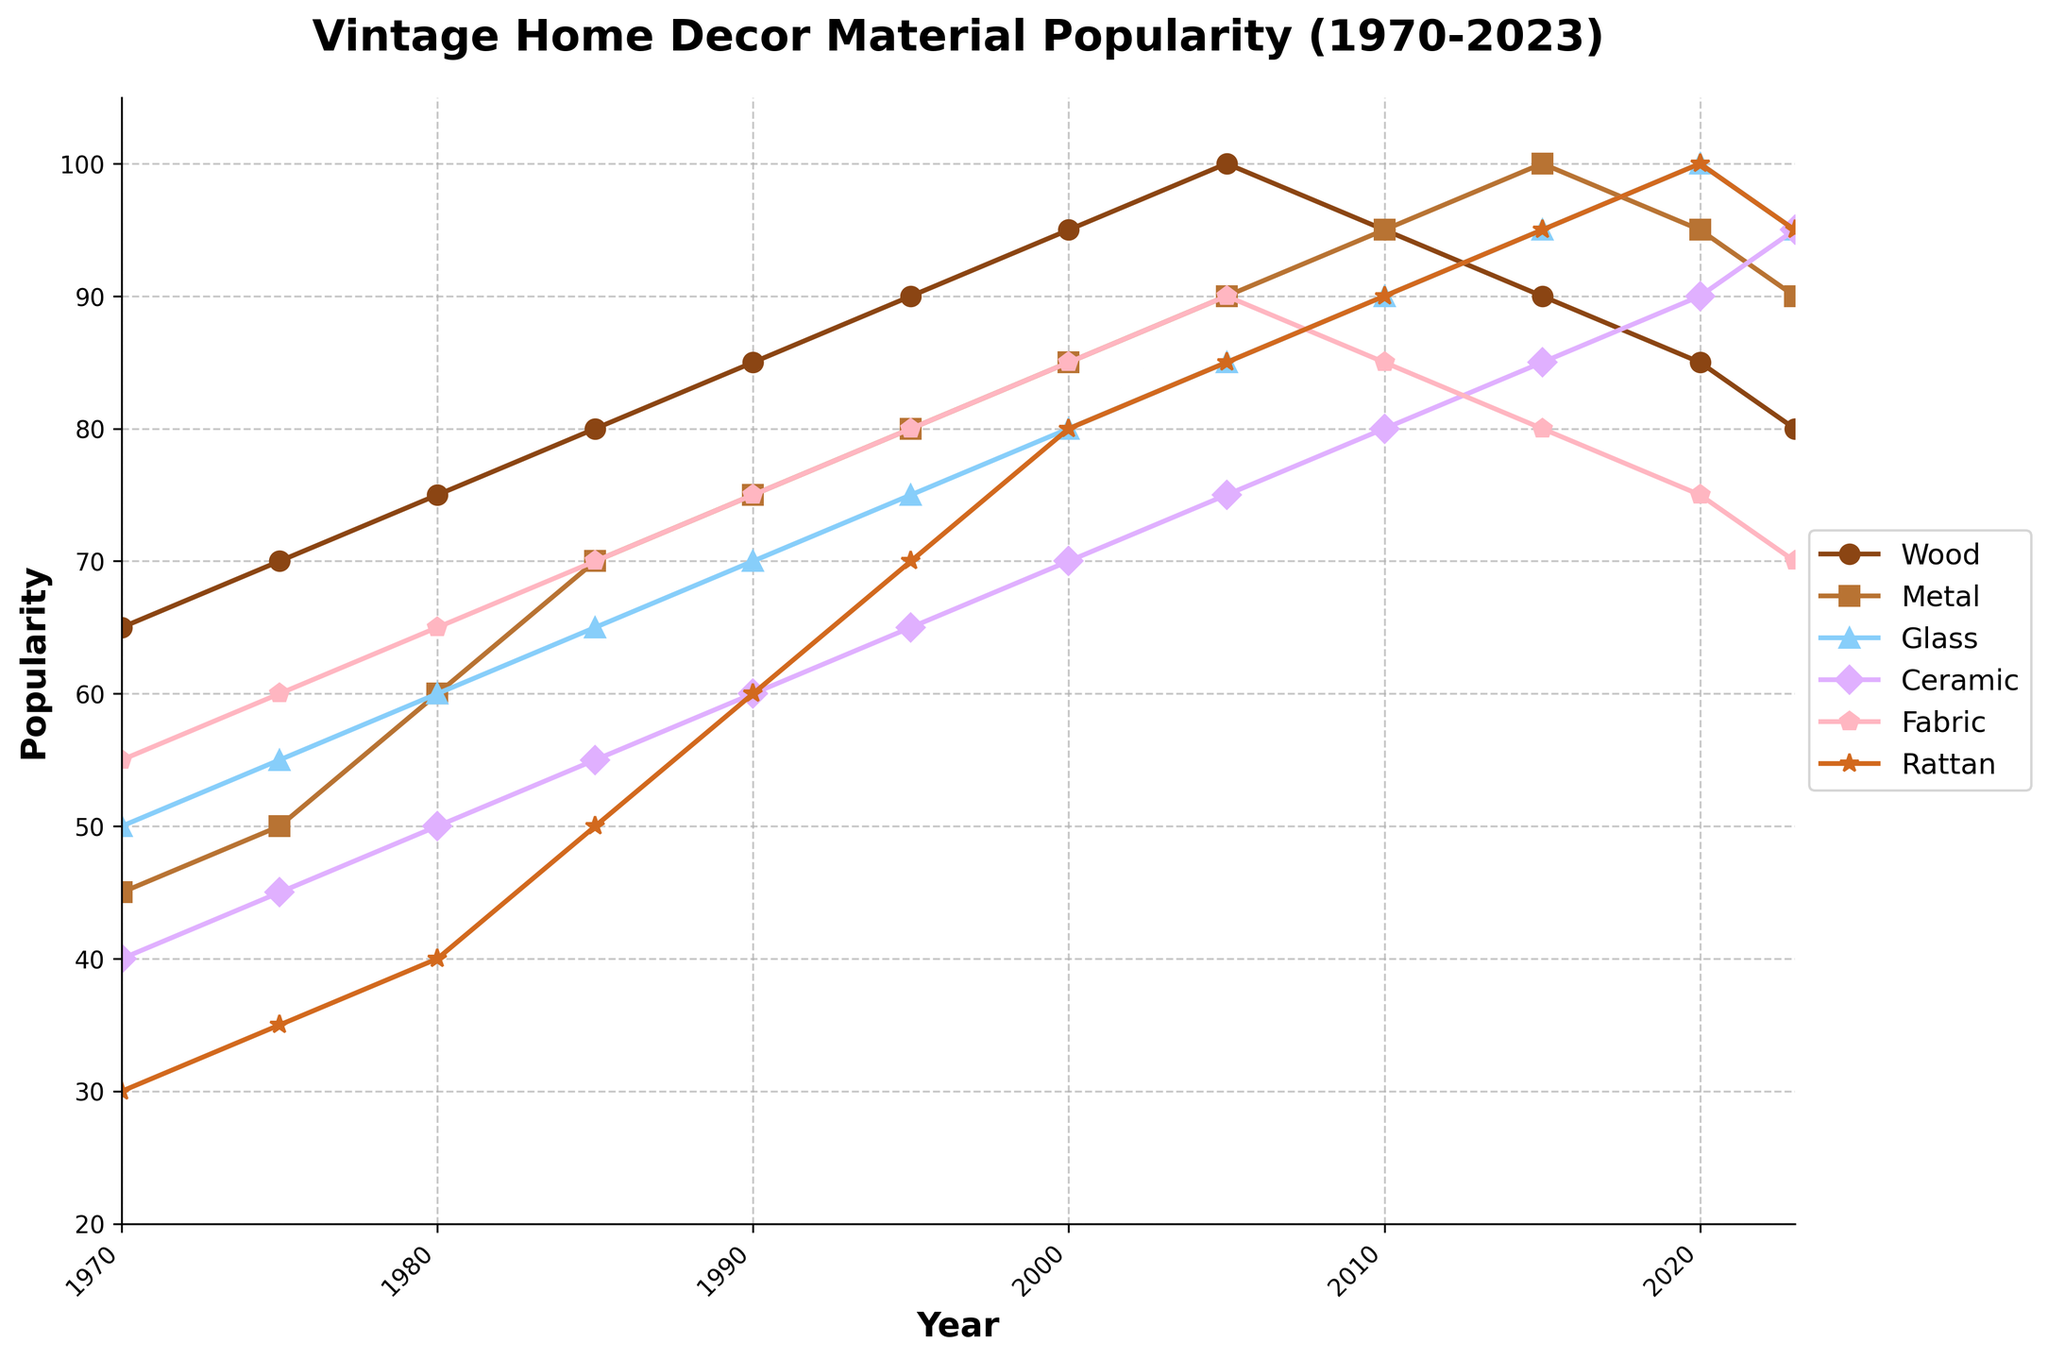Which material experienced the greatest increase in popularity from 1970 to 2023? Wood's popularity increased from 65 to 80, Metal's from 45 to 90, Glass's from 50 to 95, Ceramic's from 40 to 95, Fabric's from 55 to 70, and Rattan's from 30 to 95. The greatest increase is by Metal, Ceramic, and Rattan which all increased by 65 points.
Answer: Metal, Ceramic, Rattan Which year did Glass surpass Metal in popularity? Initially in 1970, Metal was at 45 and Glass at 50. Glass was never consistently higher than Metal after 1975 until they intersected again in 2020 with both at 95. So, the first year Metal was surpassed by Glass after an increase was 2020.
Answer: 2020 Did any material experience a decline in popularity after reaching its peak? Wood peaked at 100 in 2005 and declined afterward. Glass peaked at 100 in 2020 and slightly declined in 2023. Metal peaked at 100 in 2015 and slightly declined by 2023. Fabric peaked at 90 in 2005 and declined afterward. Everyone else either reached a peak near the end or maintained.
Answer: Yes, Wood, Glass, Metal, Fabric Compare the popularity of Ceramic and Rattan in 1985. Which one was more popular and by how much? In 1985, Ceramic had a popularity of 55, and Rattan had a popularity of 50. Therefore, Ceramic was more popular than Rattan by 5 points.
Answer: Ceramic by 5 What's the average popularity of Fabric from 1970 to 2023? Summing up the Fabric values from 1970 to 2023: 55 + 60 + 65 + 70 + 75 + 80 + 85 + 90 + 85 + 80 + 75 + 70 = 890. Dividing by the number of years (12), the average is 890/12 ≈ 74.17.
Answer: 74.17 Which material was the most popular in 2020? In 2020, the popularity values are: Wood 85, Metal 95, Glass 100, Ceramic 90, Fabric 75, Rattan 100. Among these, Glass and Rattan are tied at 100.
Answer: Glass and Rattan Between 1970 and 2023, how many times did the popularity of Wood increase by more than 5 points compared to the previous data point? The changes: 1970 to 1975 (+5), 1975 to 1980 (+5), 1980 to 1985 (+5), 1985 to 1990 (+5), 1990 to 1995 (+5), 1995 to 2000 (+5), 2000 to 2005 (+5), 2005 to 2010 (-5), 2010 to 2015 (-5), 2015 to 2020 (-5), 2020 to 2023 (-5). It never increases more than 5 points in any period.
Answer: 0 